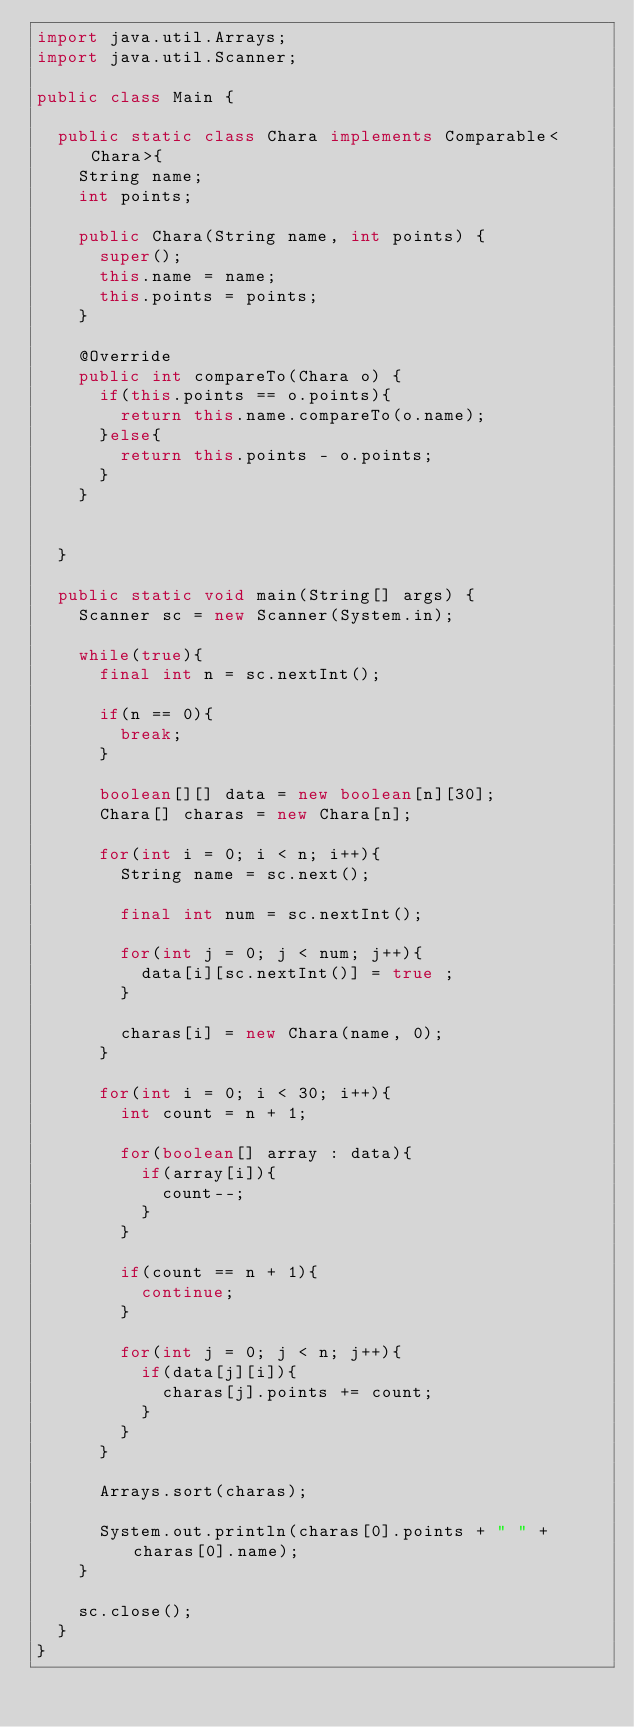Convert code to text. <code><loc_0><loc_0><loc_500><loc_500><_Java_>import java.util.Arrays;
import java.util.Scanner;

public class Main {
	
	public static class Chara implements Comparable<Chara>{
		String name;
		int points;
		
		public Chara(String name, int points) {
			super();
			this.name = name;
			this.points = points;
		}

		@Override
		public int compareTo(Chara o) {
			if(this.points == o.points){
				return this.name.compareTo(o.name);
			}else{
				return this.points - o.points;
			}
		}
		
		
	}
	
	public static void main(String[] args) {
		Scanner sc = new Scanner(System.in);
		
		while(true){
			final int n = sc.nextInt();
			
			if(n == 0){
				break;
			}
			
			boolean[][] data = new boolean[n][30];
			Chara[] charas = new Chara[n];
			
			for(int i = 0; i < n; i++){
				String name = sc.next();
				
				final int num = sc.nextInt();
				
				for(int j = 0; j < num; j++){
					data[i][sc.nextInt()] = true ;
				}
				
				charas[i] = new Chara(name, 0);
			}
			
			for(int i = 0; i < 30; i++){
				int count = n + 1;
				
				for(boolean[] array : data){
					if(array[i]){
						count--;
					}
				}
				
				if(count == n + 1){
					continue;
				}
				
				for(int j = 0; j < n; j++){
					if(data[j][i]){
						charas[j].points += count;
					}
				}
			}
			
			Arrays.sort(charas);
			
			System.out.println(charas[0].points + " " + charas[0].name);
		}
		
		sc.close();
	}
}</code> 